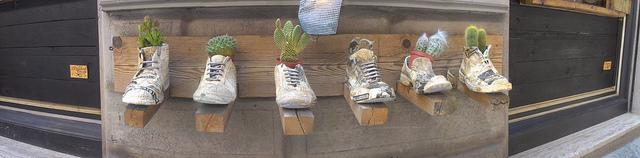Which shoes require watering more than daily? left 